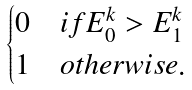<formula> <loc_0><loc_0><loc_500><loc_500>\begin{cases} 0 & i f E _ { 0 } ^ { k } > E _ { 1 } ^ { k } \\ 1 & o t h e r w i s e . \end{cases}</formula> 